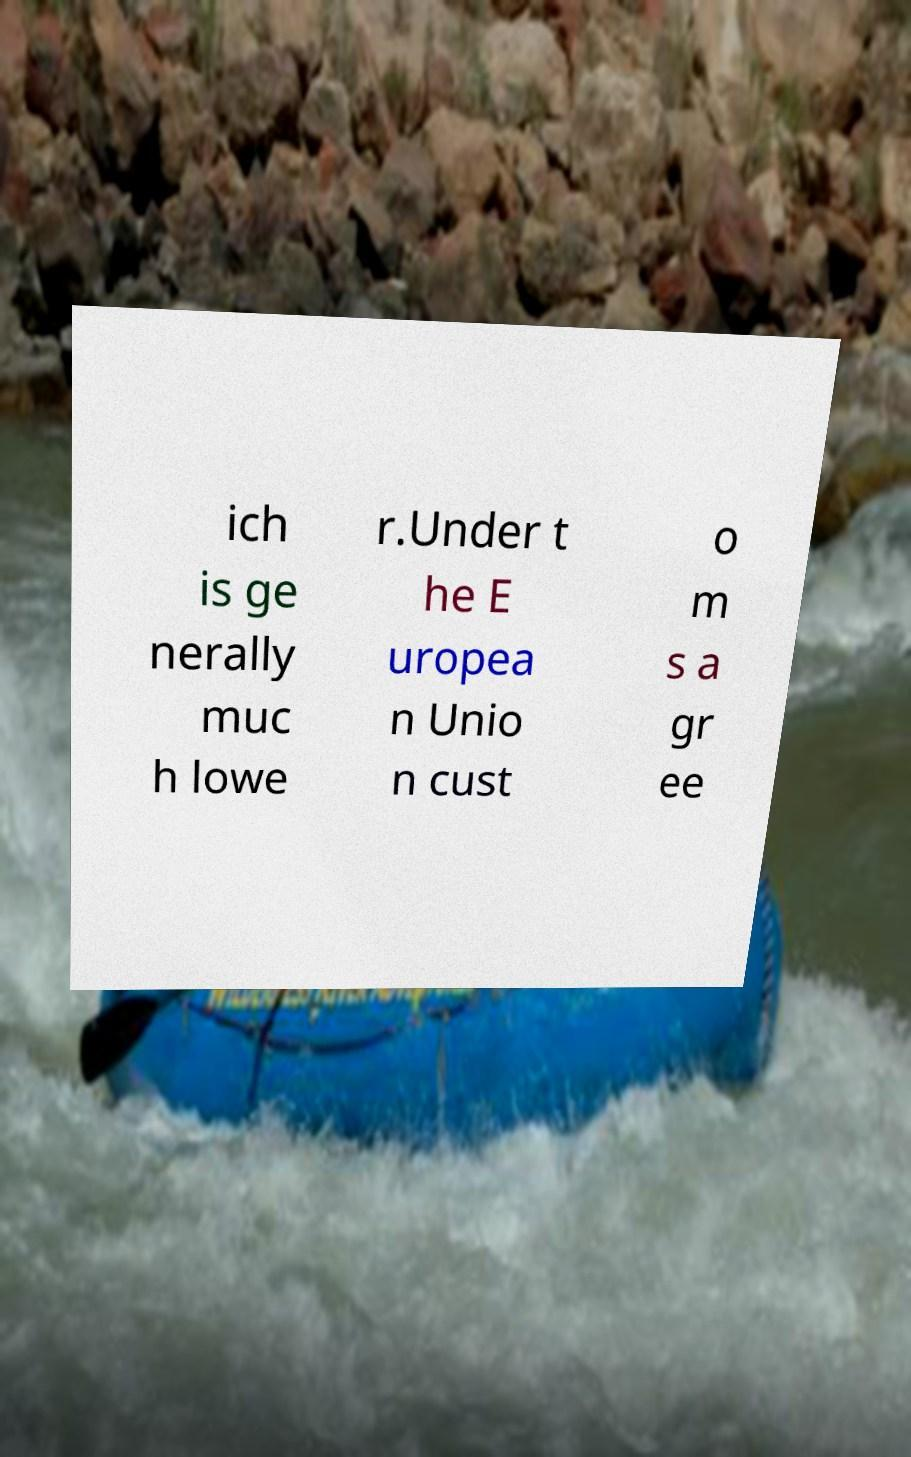I need the written content from this picture converted into text. Can you do that? ich is ge nerally muc h lowe r.Under t he E uropea n Unio n cust o m s a gr ee 